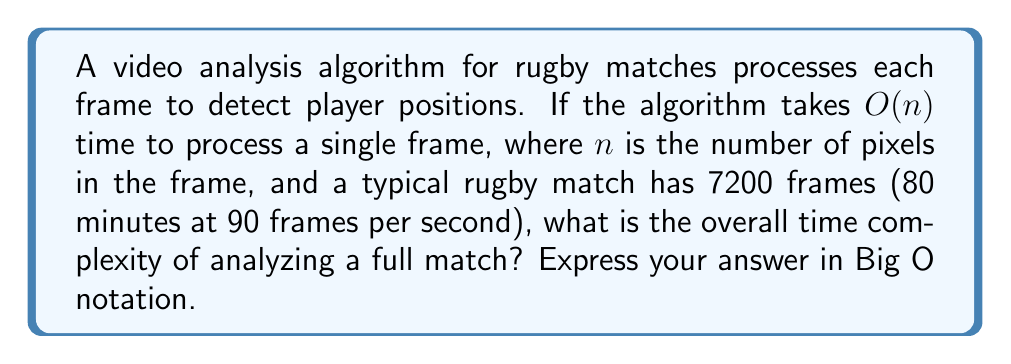Show me your answer to this math problem. Let's approach this step-by-step:

1) First, we need to understand what the question is asking. We're looking at the time complexity of processing an entire rugby match, given that:
   - Each frame takes $O(n)$ time to process, where $n$ is the number of pixels
   - There are 7200 frames in a match

2) The key here is to recognize that we're performing the same operation (processing a frame) multiple times.

3) When we perform an operation with complexity $O(f(n))$ a total of $m$ times, the overall complexity becomes $O(m \cdot f(n))$.

4) In this case:
   - The operation (processing a frame) has complexity $O(n)$
   - We're doing this 7200 times

5) Therefore, the overall complexity is:

   $O(7200 \cdot n)$

6) In Big O notation, we drop constant factors. 7200 is a constant, so we can simplify this to:

   $O(n)$

This might seem counterintuitive at first, but remember that $n$ (the number of pixels) is typically much larger than the number of frames. The number of frames is a constant that doesn't change with input size, while $n$ can vary depending on the resolution of the video.
Answer: $O(n)$ 